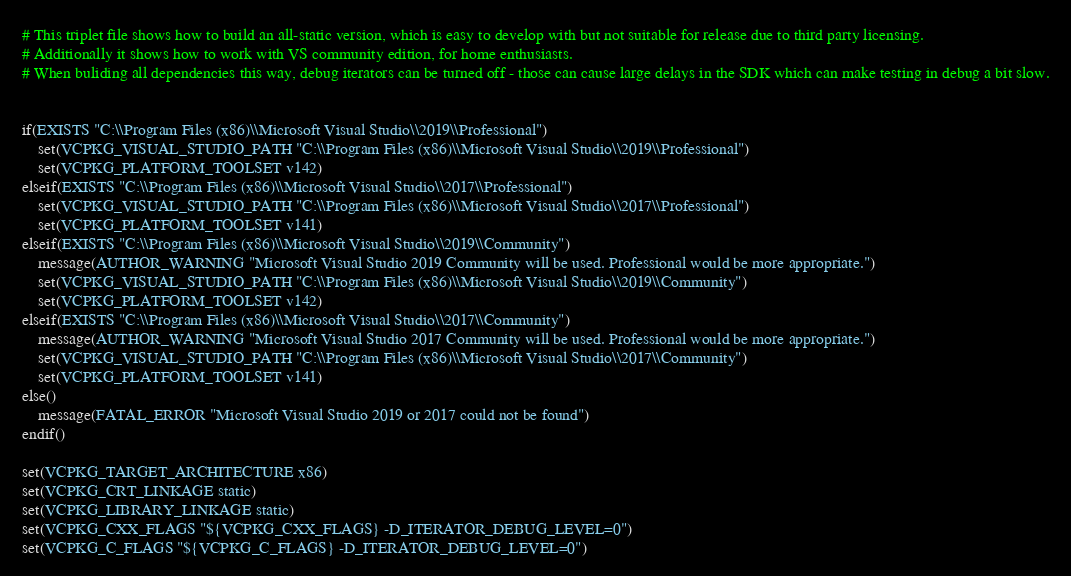Convert code to text. <code><loc_0><loc_0><loc_500><loc_500><_CMake_># This triplet file shows how to build an all-static version, which is easy to develop with but not suitable for release due to third party licensing.
# Additionally it shows how to work with VS community edition, for home enthusiasts.
# When buliding all dependencies this way, debug iterators can be turned off - those can cause large delays in the SDK which can make testing in debug a bit slow.


if(EXISTS "C:\\Program Files (x86)\\Microsoft Visual Studio\\2019\\Professional")
    set(VCPKG_VISUAL_STUDIO_PATH "C:\\Program Files (x86)\\Microsoft Visual Studio\\2019\\Professional")
    set(VCPKG_PLATFORM_TOOLSET v142)
elseif(EXISTS "C:\\Program Files (x86)\\Microsoft Visual Studio\\2017\\Professional")
    set(VCPKG_VISUAL_STUDIO_PATH "C:\\Program Files (x86)\\Microsoft Visual Studio\\2017\\Professional")
    set(VCPKG_PLATFORM_TOOLSET v141)
elseif(EXISTS "C:\\Program Files (x86)\\Microsoft Visual Studio\\2019\\Community")
    message(AUTHOR_WARNING "Microsoft Visual Studio 2019 Community will be used. Professional would be more appropriate.")
    set(VCPKG_VISUAL_STUDIO_PATH "C:\\Program Files (x86)\\Microsoft Visual Studio\\2019\\Community")
    set(VCPKG_PLATFORM_TOOLSET v142)
elseif(EXISTS "C:\\Program Files (x86)\\Microsoft Visual Studio\\2017\\Community")
    message(AUTHOR_WARNING "Microsoft Visual Studio 2017 Community will be used. Professional would be more appropriate.")
    set(VCPKG_VISUAL_STUDIO_PATH "C:\\Program Files (x86)\\Microsoft Visual Studio\\2017\\Community")
    set(VCPKG_PLATFORM_TOOLSET v141)
else()
    message(FATAL_ERROR "Microsoft Visual Studio 2019 or 2017 could not be found")
endif()

set(VCPKG_TARGET_ARCHITECTURE x86)
set(VCPKG_CRT_LINKAGE static)
set(VCPKG_LIBRARY_LINKAGE static)
set(VCPKG_CXX_FLAGS "${VCPKG_CXX_FLAGS} -D_ITERATOR_DEBUG_LEVEL=0")
set(VCPKG_C_FLAGS "${VCPKG_C_FLAGS} -D_ITERATOR_DEBUG_LEVEL=0")
</code> 